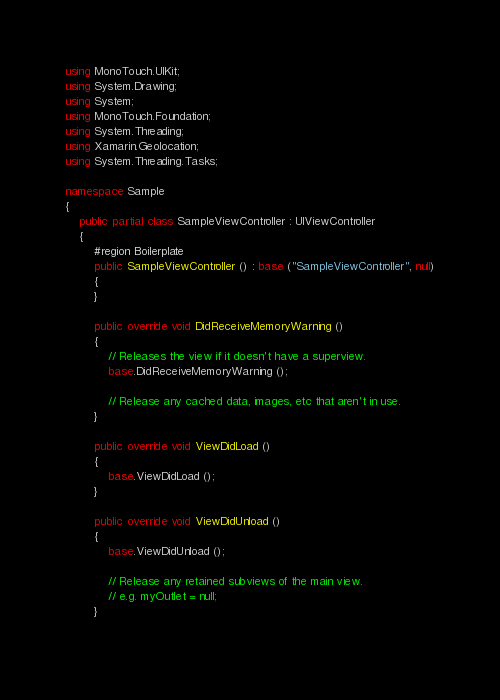Convert code to text. <code><loc_0><loc_0><loc_500><loc_500><_C#_>using MonoTouch.UIKit;
using System.Drawing;
using System;
using MonoTouch.Foundation;
using System.Threading;
using Xamarin.Geolocation;
using System.Threading.Tasks;

namespace Sample
{
	public partial class SampleViewController : UIViewController
	{
		#region Boilerplate
		public SampleViewController () : base ("SampleViewController", null)
		{
		}
		
		public override void DidReceiveMemoryWarning ()
		{
			// Releases the view if it doesn't have a superview.
			base.DidReceiveMemoryWarning ();
			
			// Release any cached data, images, etc that aren't in use.
		}
		
		public override void ViewDidLoad ()
		{
			base.ViewDidLoad ();
		}

		public override void ViewDidUnload ()
		{
			base.ViewDidUnload ();
			
			// Release any retained subviews of the main view.
			// e.g. myOutlet = null;
		}
		</code> 